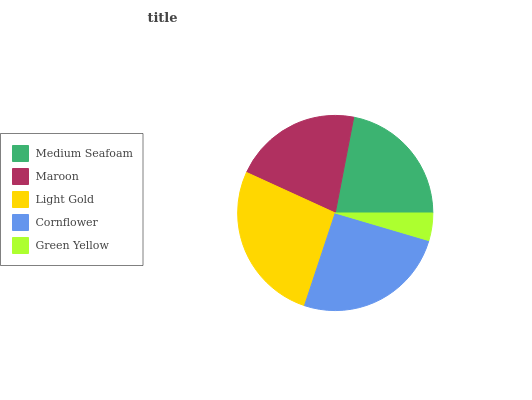Is Green Yellow the minimum?
Answer yes or no. Yes. Is Light Gold the maximum?
Answer yes or no. Yes. Is Maroon the minimum?
Answer yes or no. No. Is Maroon the maximum?
Answer yes or no. No. Is Medium Seafoam greater than Maroon?
Answer yes or no. Yes. Is Maroon less than Medium Seafoam?
Answer yes or no. Yes. Is Maroon greater than Medium Seafoam?
Answer yes or no. No. Is Medium Seafoam less than Maroon?
Answer yes or no. No. Is Medium Seafoam the high median?
Answer yes or no. Yes. Is Medium Seafoam the low median?
Answer yes or no. Yes. Is Maroon the high median?
Answer yes or no. No. Is Light Gold the low median?
Answer yes or no. No. 